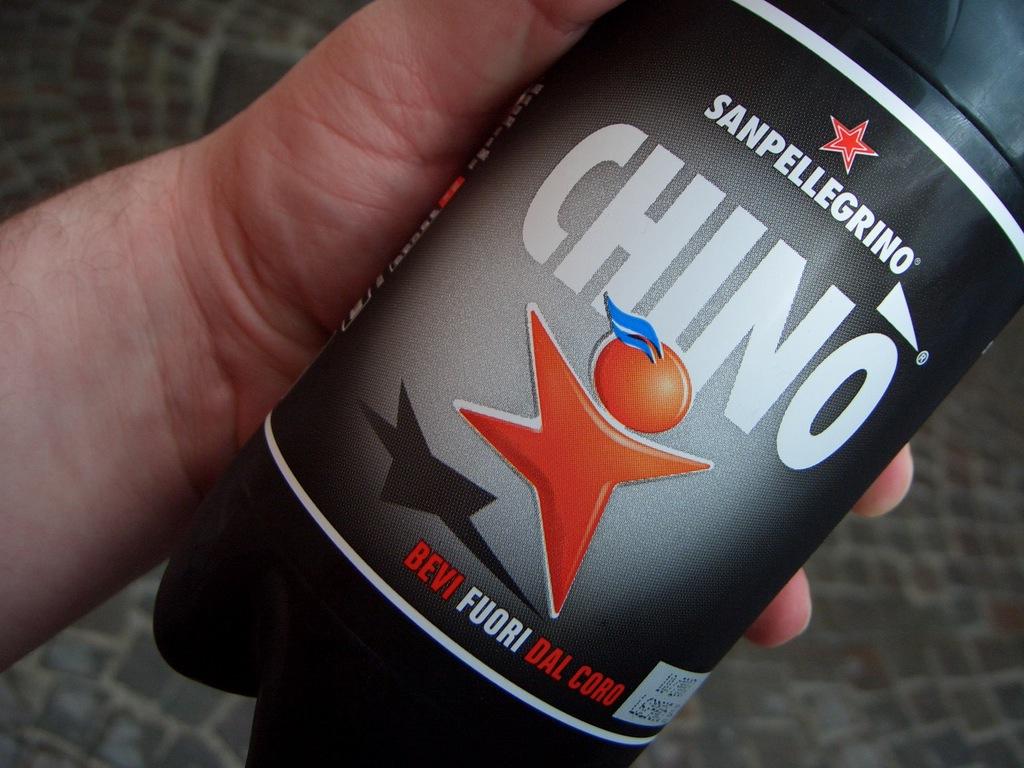What is that drink?
Keep it short and to the point. Chino. 